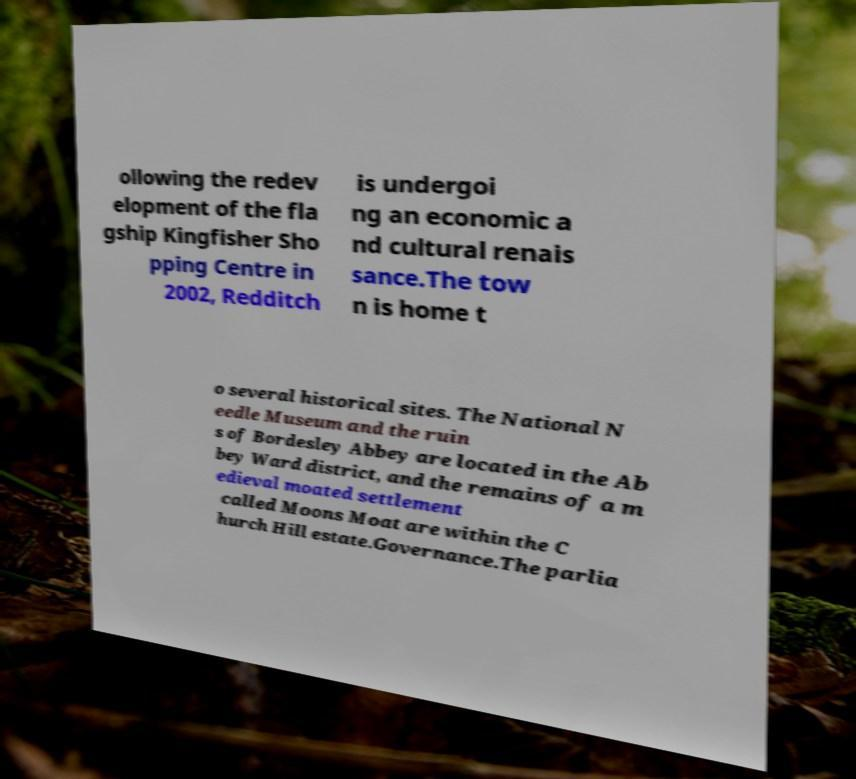Please identify and transcribe the text found in this image. ollowing the redev elopment of the fla gship Kingfisher Sho pping Centre in 2002, Redditch is undergoi ng an economic a nd cultural renais sance.The tow n is home t o several historical sites. The National N eedle Museum and the ruin s of Bordesley Abbey are located in the Ab bey Ward district, and the remains of a m edieval moated settlement called Moons Moat are within the C hurch Hill estate.Governance.The parlia 